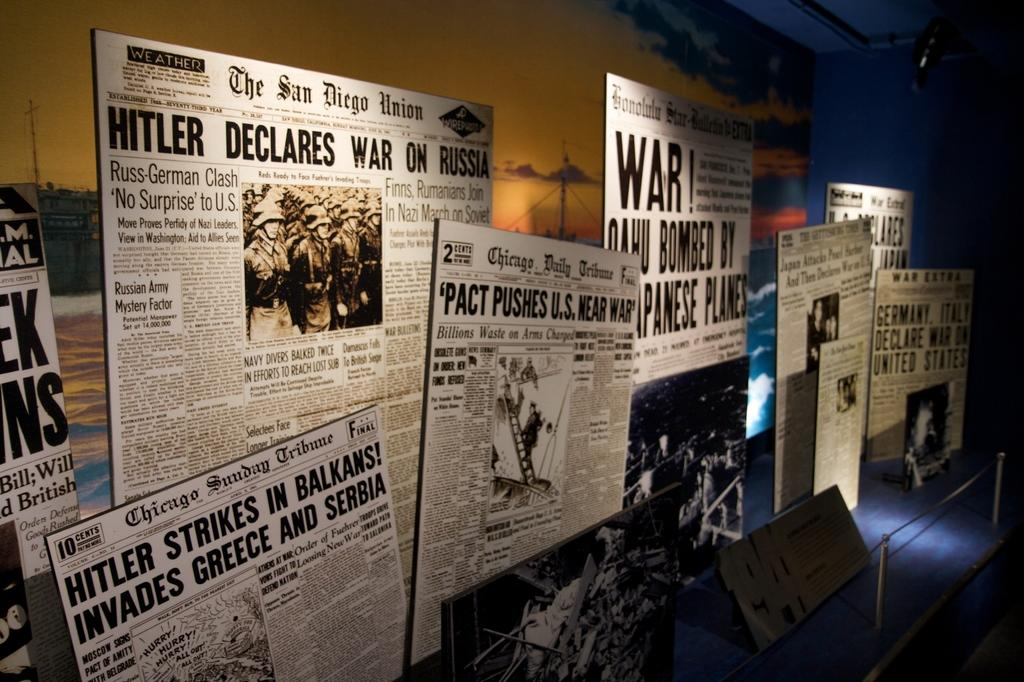Provide a one-sentence caption for the provided image. Political newspapers that speak of the War and Hitler stand up in a museum. 